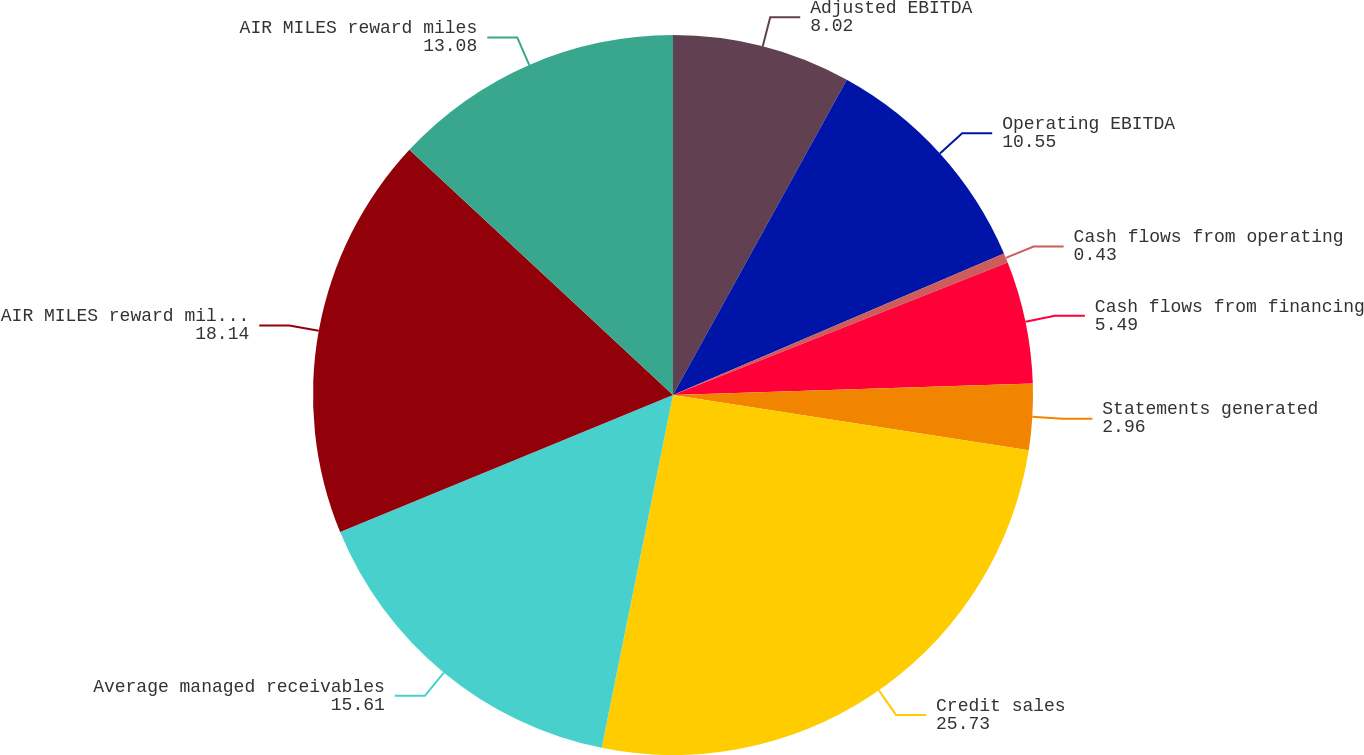Convert chart. <chart><loc_0><loc_0><loc_500><loc_500><pie_chart><fcel>Adjusted EBITDA<fcel>Operating EBITDA<fcel>Cash flows from operating<fcel>Cash flows from financing<fcel>Statements generated<fcel>Credit sales<fcel>Average managed receivables<fcel>AIR MILES reward miles issued<fcel>AIR MILES reward miles<nl><fcel>8.02%<fcel>10.55%<fcel>0.43%<fcel>5.49%<fcel>2.96%<fcel>25.73%<fcel>15.61%<fcel>18.14%<fcel>13.08%<nl></chart> 